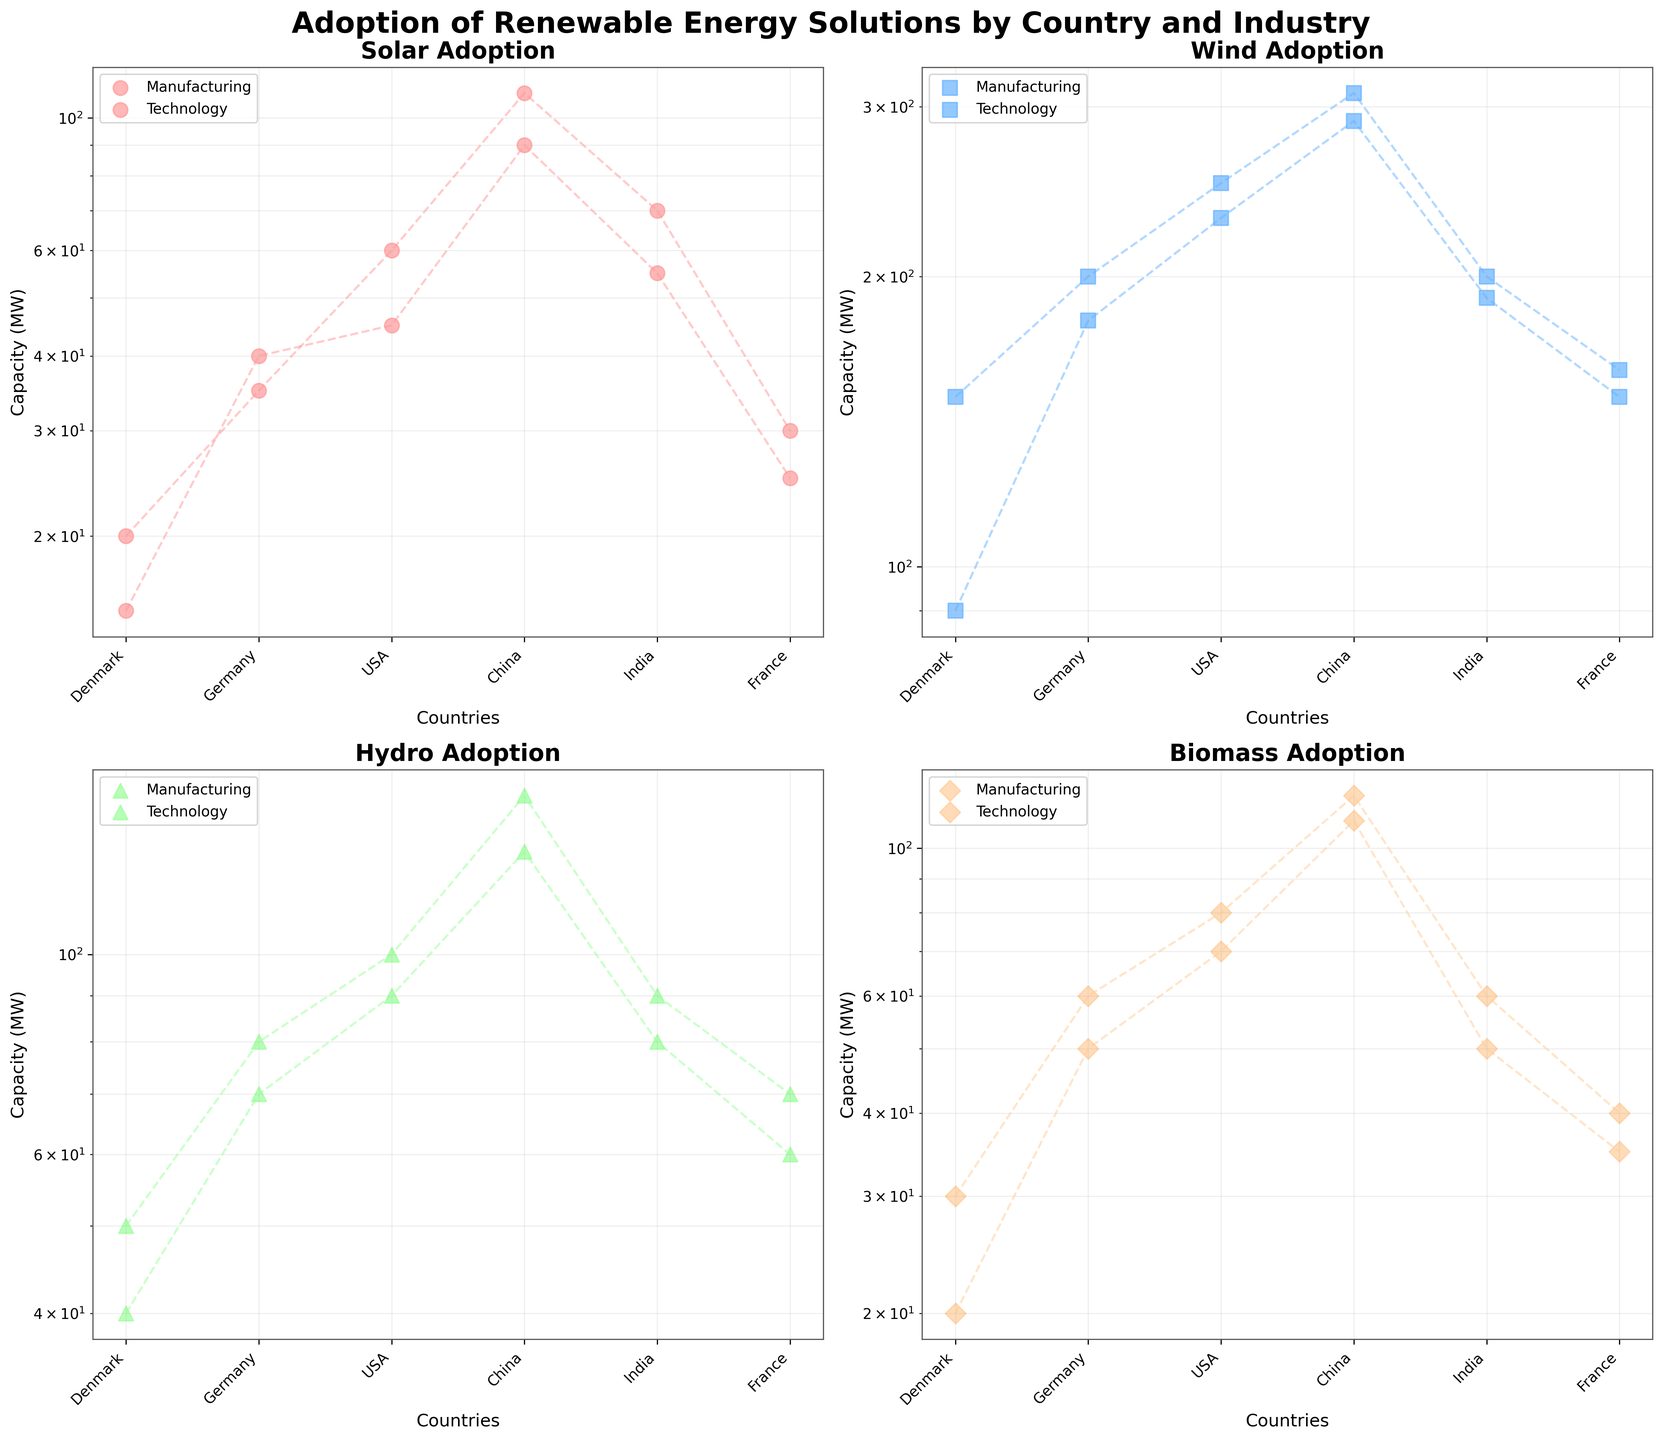How many countries are represented in the plot? The x-axis shows the unique countries. By counting them, we see there are six different countries.
Answer: Six Which industry generally has higher values for Solar energy adoption in the figure? By comparing the values for Solar energy adoption in both Manufacturing and Technology across all subplots, it is apparent that Manufacturing tends to have higher values than Technology.
Answer: Manufacturing What is the total Biomass capacity for the USA in both industries? The Biomass capacity in Manufacturing for the USA is 80 MW and in Technology it is 70 MW. Summing these values gives 80 + 70.
Answer: 150 MW Which country has the highest Hydro capacity for the Manufacturing industry? By examining the Hydro values for the Manufacturing industry across different countries, China has the highest value at 150 MW.
Answer: China Which energy type has the greatest difference between the maximum and minimum values within the Technology industry? For each energy type within the Technology industry, we find the maximum and minimum values. The differences are: Solar (90-15), Wind (290-90), Hydro (130-40), Biomass (110-20). Wind has the greatest difference.
Answer: Wind Do any industries overlap in Wind capacity for France and Germany within the subplots? By visually checking the Wind capacity data points for France and Germany across both industries in the Wind subplot, it is clear that there is no overlap.
Answer: No What is the average Solar energy capacity for Technology industries across all countries? The Solar capacities for Technology industries are 15, 40, 45, 90, 55, and 25. Summing these and dividing by their count: (15 + 40 + 45 + 90 + 55 + 25)/6.
Answer: 45 MW Does Denmark have a higher Wind adoption in the Manufacturing industry compared to India in the same industry? Comparing the values: Denmark has 150 MW and India has 200 MW of Wind adoption in Manufacturing.
Answer: No What trend can you observe in Biomass adoption between Technology and Manufacturing industries for China? In China, the Biomass adoption in the Technology industry is 110 MW, whereas in the Manufacturing industry it is 120 MW, showing a slight decrease in Technology compared to Manufacturing.
Answer: Decrease in Technology Which energy type has the smallest y-axis range on the log scale for the Technology industry? By analyzing the range (difference between maximum and minimum values) on the log scale for each energy type in the Technology industry: Solar (90-15), Wind (290-90), Hydro (130-40), Biomass (110-20), Hydro has the smallest range.
Answer: Hydro 